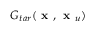<formula> <loc_0><loc_0><loc_500><loc_500>G _ { t a r } ( x , x _ { u } )</formula> 